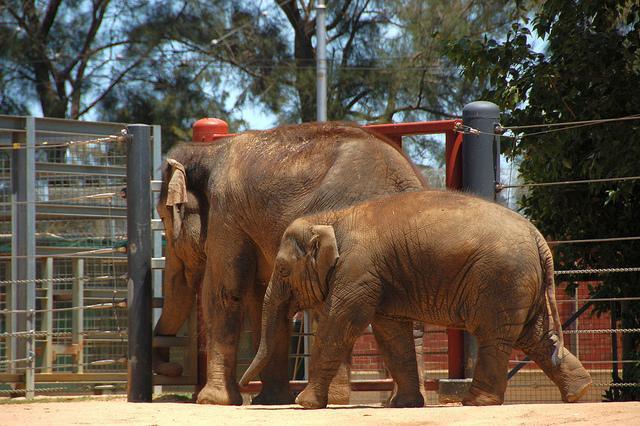How many elephants can be seen?
Give a very brief answer. 2. How many people are standing on a white line?
Give a very brief answer. 0. 